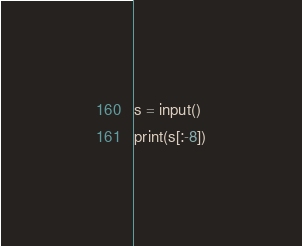Convert code to text. <code><loc_0><loc_0><loc_500><loc_500><_Python_>s = input()
print(s[:-8])
</code> 